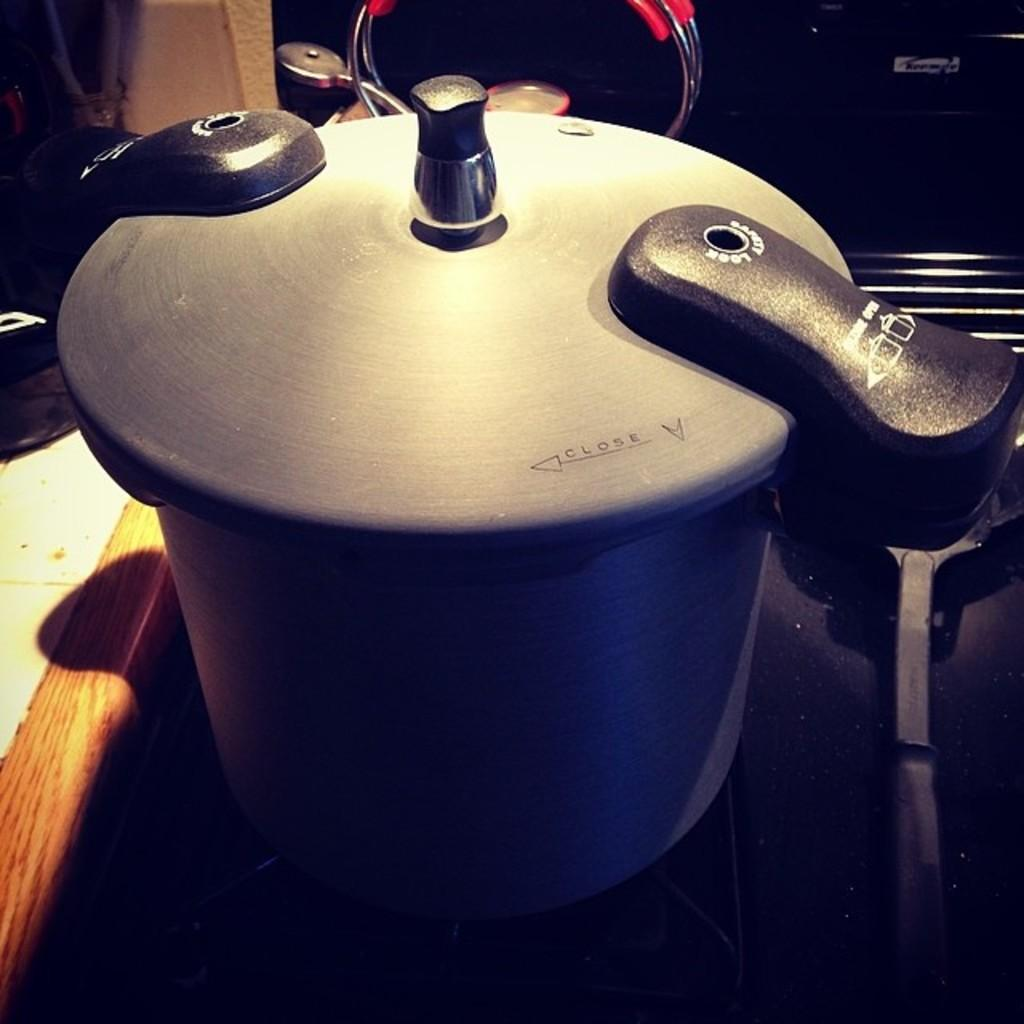<image>
Present a compact description of the photo's key features. Pressure cooker needs to been turned left to close 